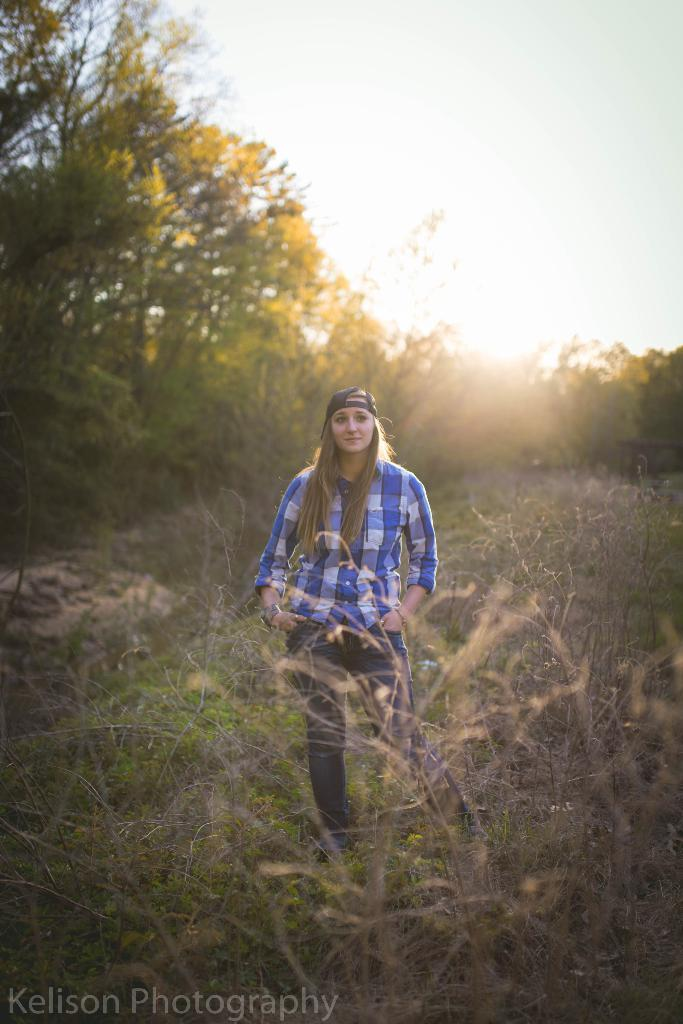Who is present in the image? There is a woman in the image. What is the woman's position in the image? The woman is on the ground. What can be seen in the background of the image? There are trees and sky visible in the background of the image. Is there any text in the image? Yes, there is text in the bottom left corner of the image. What type of mint can be seen growing in the wilderness in the image? There is no mint or wilderness present in the image; it features a woman on the ground with trees and sky in the background. 